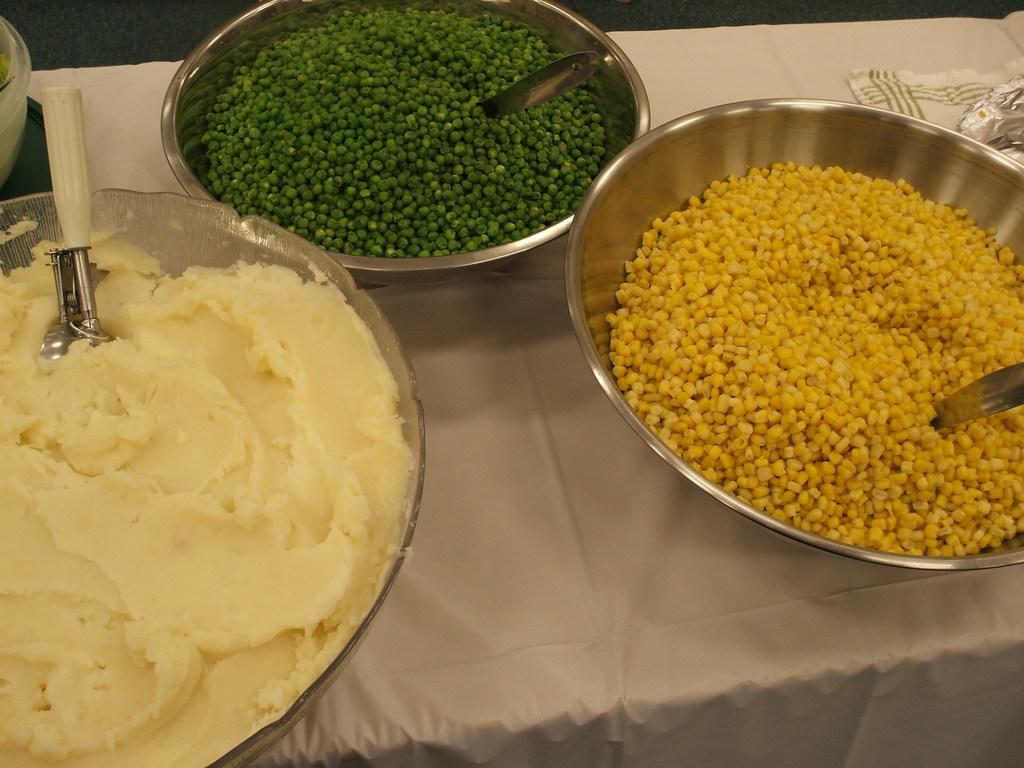What is the main object in the center of the image? There is a table in the center of the image. What is placed on the table? There are bowls on the table. What is inside the bowls? The bowls contain food items. Can you see any smoke coming from the food in the image? There is no smoke present in the image; it only shows bowls containing food items on a table. 